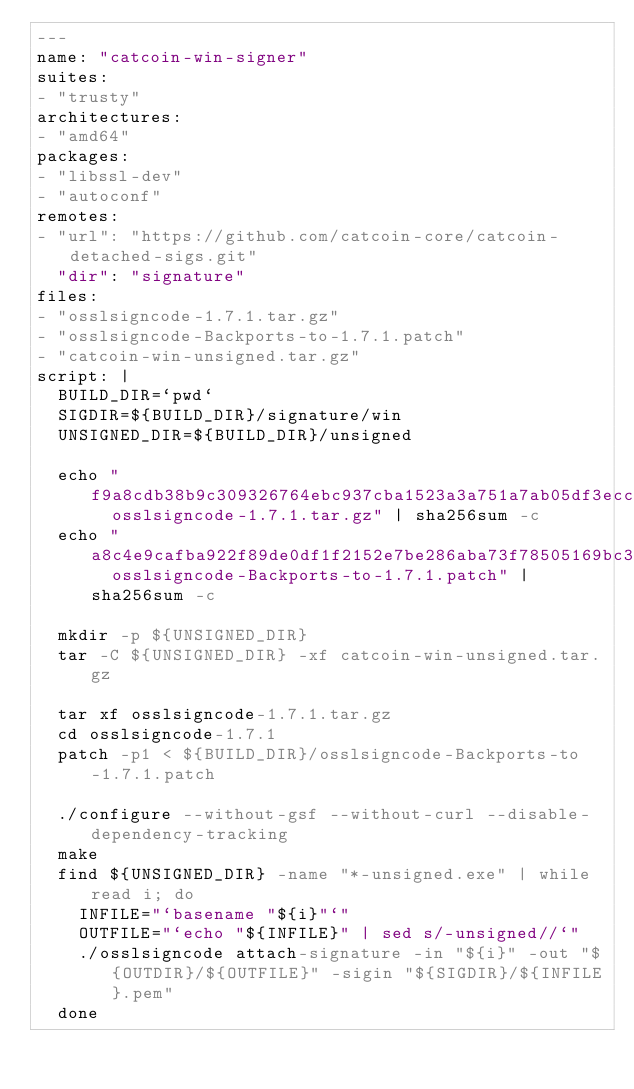<code> <loc_0><loc_0><loc_500><loc_500><_YAML_>---
name: "catcoin-win-signer"
suites:
- "trusty"
architectures:
- "amd64"
packages:
- "libssl-dev"
- "autoconf"
remotes:
- "url": "https://github.com/catcoin-core/catcoin-detached-sigs.git"
  "dir": "signature"
files:
- "osslsigncode-1.7.1.tar.gz"
- "osslsigncode-Backports-to-1.7.1.patch"
- "catcoin-win-unsigned.tar.gz"
script: |
  BUILD_DIR=`pwd`
  SIGDIR=${BUILD_DIR}/signature/win
  UNSIGNED_DIR=${BUILD_DIR}/unsigned

  echo "f9a8cdb38b9c309326764ebc937cba1523a3a751a7ab05df3ecc99d18ae466c9  osslsigncode-1.7.1.tar.gz" | sha256sum -c
  echo "a8c4e9cafba922f89de0df1f2152e7be286aba73f78505169bc351a7938dd911  osslsigncode-Backports-to-1.7.1.patch" | sha256sum -c

  mkdir -p ${UNSIGNED_DIR}
  tar -C ${UNSIGNED_DIR} -xf catcoin-win-unsigned.tar.gz

  tar xf osslsigncode-1.7.1.tar.gz
  cd osslsigncode-1.7.1
  patch -p1 < ${BUILD_DIR}/osslsigncode-Backports-to-1.7.1.patch

  ./configure --without-gsf --without-curl --disable-dependency-tracking
  make
  find ${UNSIGNED_DIR} -name "*-unsigned.exe" | while read i; do
    INFILE="`basename "${i}"`"
    OUTFILE="`echo "${INFILE}" | sed s/-unsigned//`"
    ./osslsigncode attach-signature -in "${i}" -out "${OUTDIR}/${OUTFILE}" -sigin "${SIGDIR}/${INFILE}.pem"
  done
</code> 